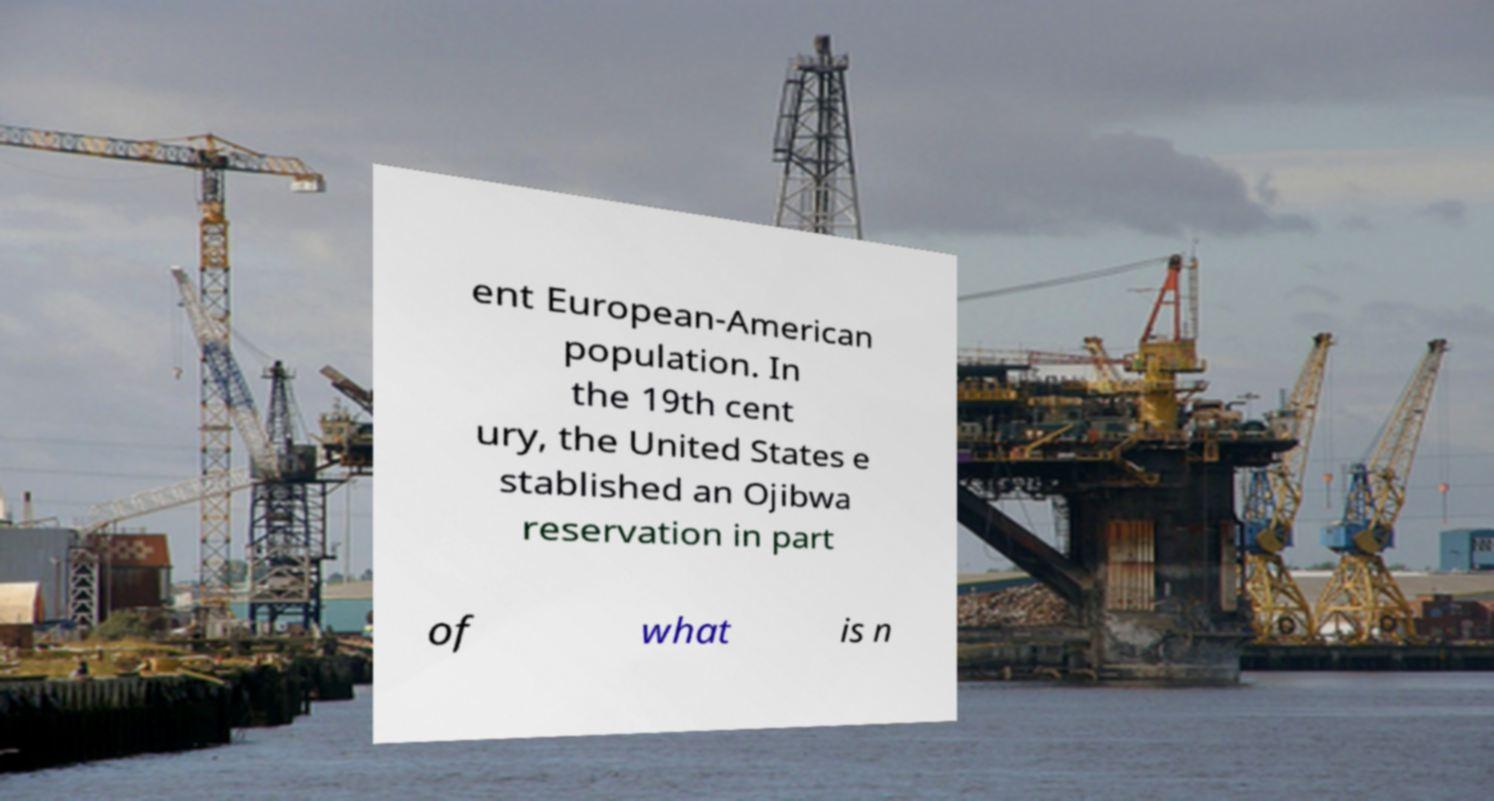What messages or text are displayed in this image? I need them in a readable, typed format. ent European-American population. In the 19th cent ury, the United States e stablished an Ojibwa reservation in part of what is n 